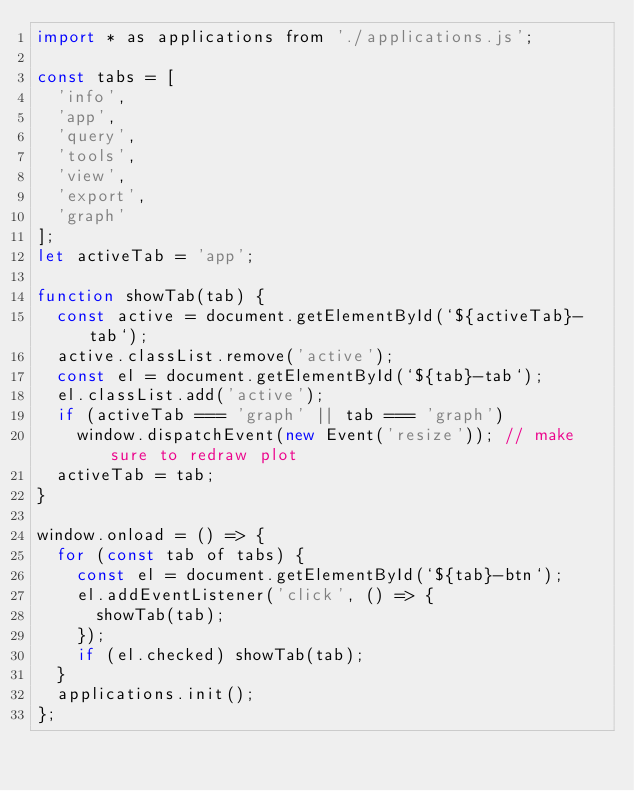<code> <loc_0><loc_0><loc_500><loc_500><_JavaScript_>import * as applications from './applications.js';

const tabs = [
	'info',
	'app',
	'query',
	'tools',
	'view',
	'export',
	'graph'
];
let activeTab = 'app';

function showTab(tab) {
	const active = document.getElementById(`${activeTab}-tab`);
	active.classList.remove('active');
	const el = document.getElementById(`${tab}-tab`);
	el.classList.add('active');
	if (activeTab === 'graph' || tab === 'graph')
		window.dispatchEvent(new Event('resize')); // make sure to redraw plot
	activeTab = tab;
}

window.onload = () => {
	for (const tab of tabs) {
		const el = document.getElementById(`${tab}-btn`);
		el.addEventListener('click', () => {
			showTab(tab);
		});
		if (el.checked) showTab(tab);
	}
	applications.init();
};
</code> 